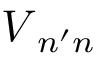Convert formula to latex. <formula><loc_0><loc_0><loc_500><loc_500>V _ { n ^ { \prime } n }</formula> 